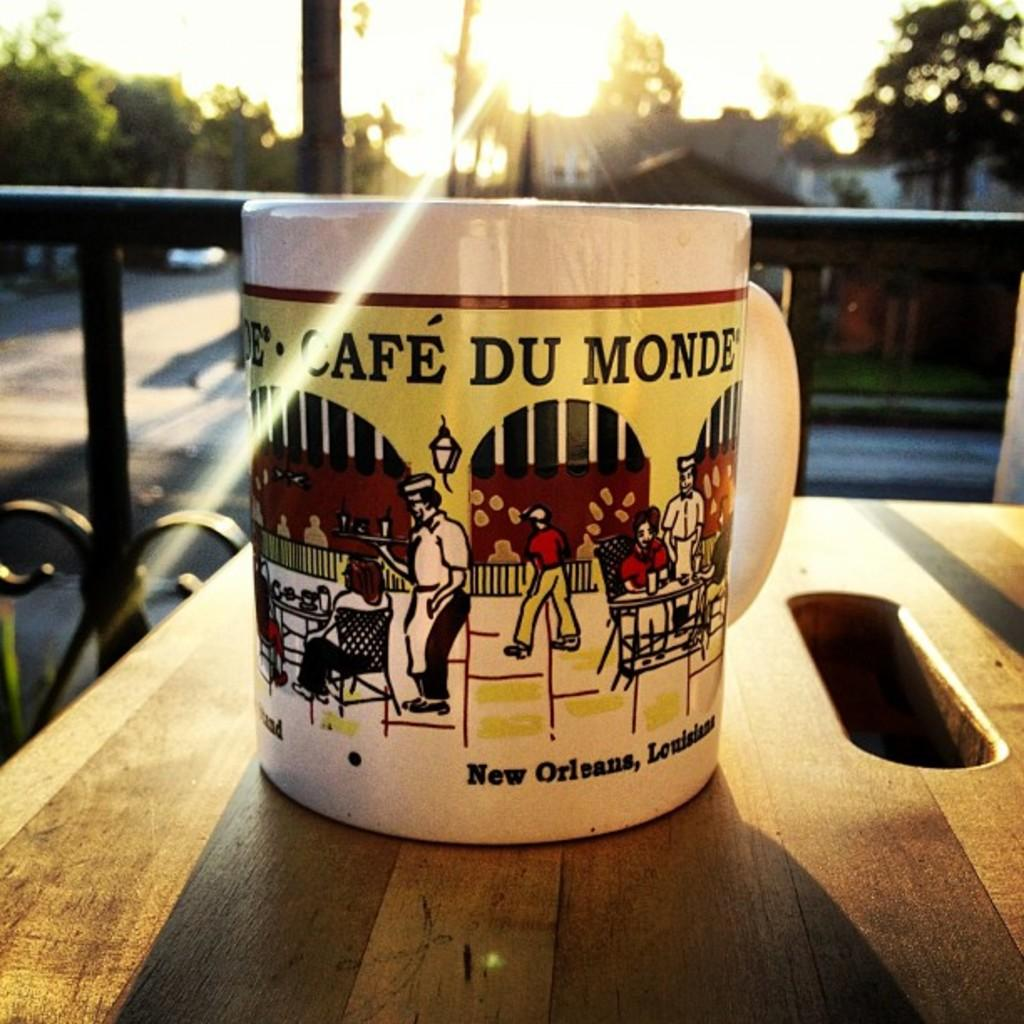Provide a one-sentence caption for the provided image. a coffee mug of cafe du monde in new orleans. 